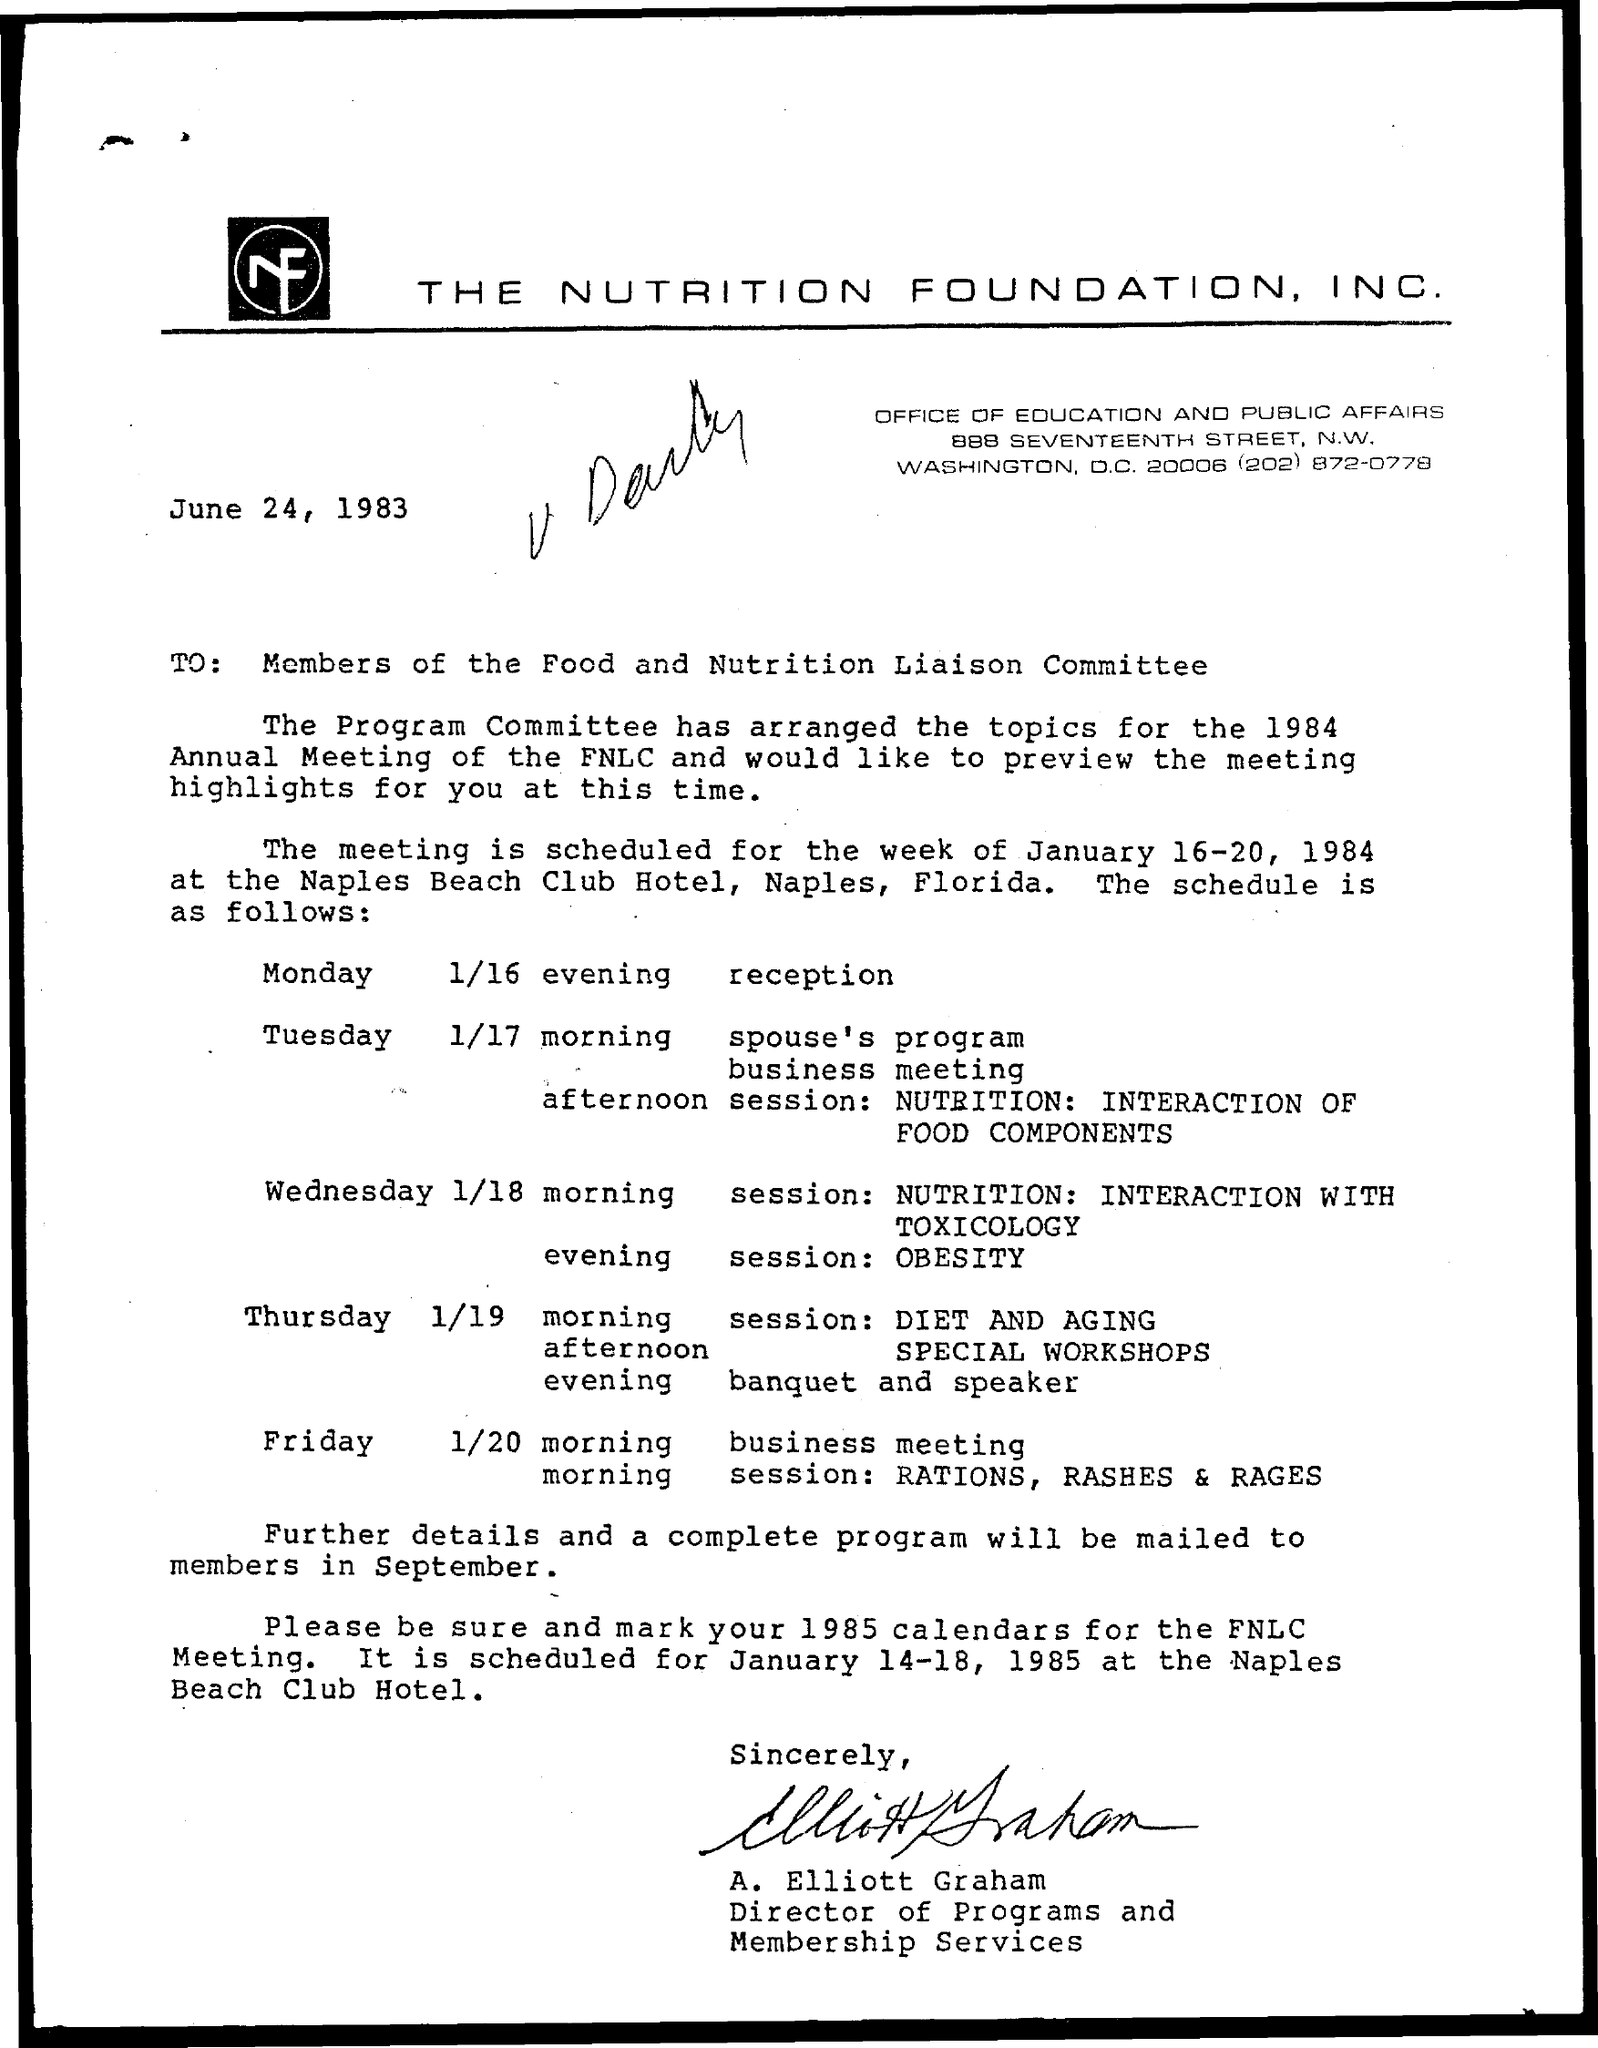Outline some significant characteristics in this image. The evening session on Wednesday is named 'obesity'. The morning session on Thursday is named 'Diet and Aging'. The date mentioned is June 24, 1983. 